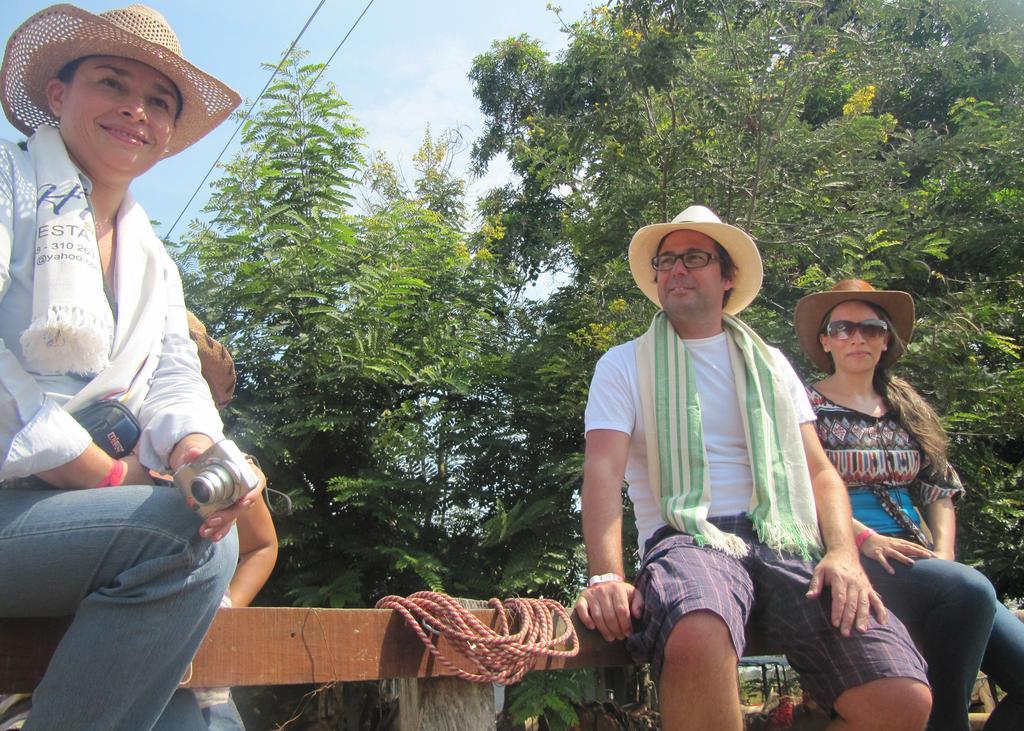How would you summarize this image in a sentence or two? This image consists of three persons sitting on a wooden stick. On the left, the person is holding a camera. On the right, the two persons are wearing hats. In the background, there are tree. In the middle, we can see a wooden stick along with rope. 